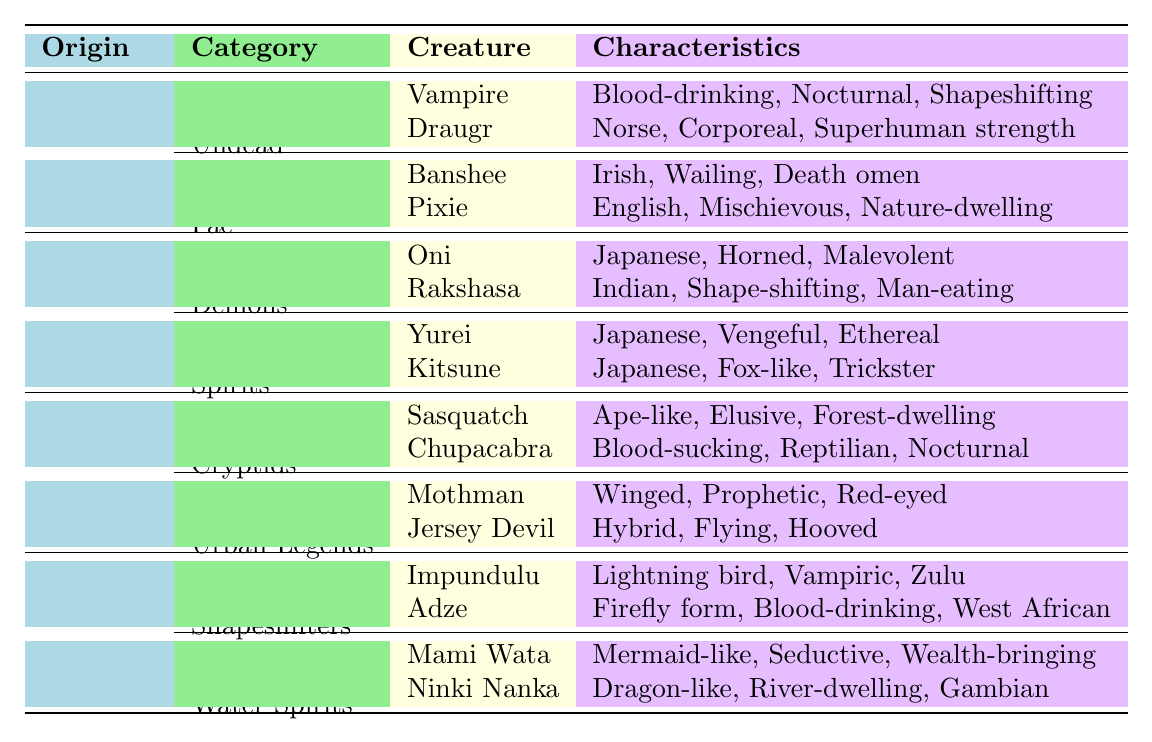What is the origin of the Banshee? The Banshee is categorized under Fae and originates from European folklore.
Answer: European How many types of Cryptids are listed in the table? There is one type of Cryptids, which includes two creatures: Sasquatch and Chupacabra.
Answer: 1 What characteristics are associated with the Yurei? The Yurei has three characteristics: Japanese, Vengeful, and Ethereal. Each characteristic is provided as per the content of the table.
Answer: Japanese, Vengeful, Ethereal Are there any Shapeshifters from American folklore in the table? The table does not list any Shapeshifters under American folklore; they are categorized under African folklore instead.
Answer: False Which type of creature from Asian origin has the characteristics of being horned and malevolent? The Oni is the creature from Asian origin with those characteristics, listed under the Demons category.
Answer: Oni How many total creatures from African folklore are categorized as Water Spirits? There are two creatures under Water Spirits: Mami Wata and Ninki Nanka.
Answer: 2 Is there a creature listed that has the characteristics of being blood-drinking and nocturnal? The Chupacabra fits these characteristics and falls under the Cryptids category in American folklore.
Answer: Yes Which category contains the most creatures, and what is the count? The Undead category has the highest count with two creatures: Vampire and Draugr.
Answer: Undead, 2 What do all creatures listed under the Fae category share? All the creatures under the Fae category (Banshee and Pixie) are tied to European folklore origins and have connections to nature or supernatural events.
Answer: European folklore, nature-related Which creature is described as having a blood-drinking characteristic under African folklore? Both Impundulu and Adze have blood-drinking as a shared characteristic.
Answer: Impundulu, Adze 